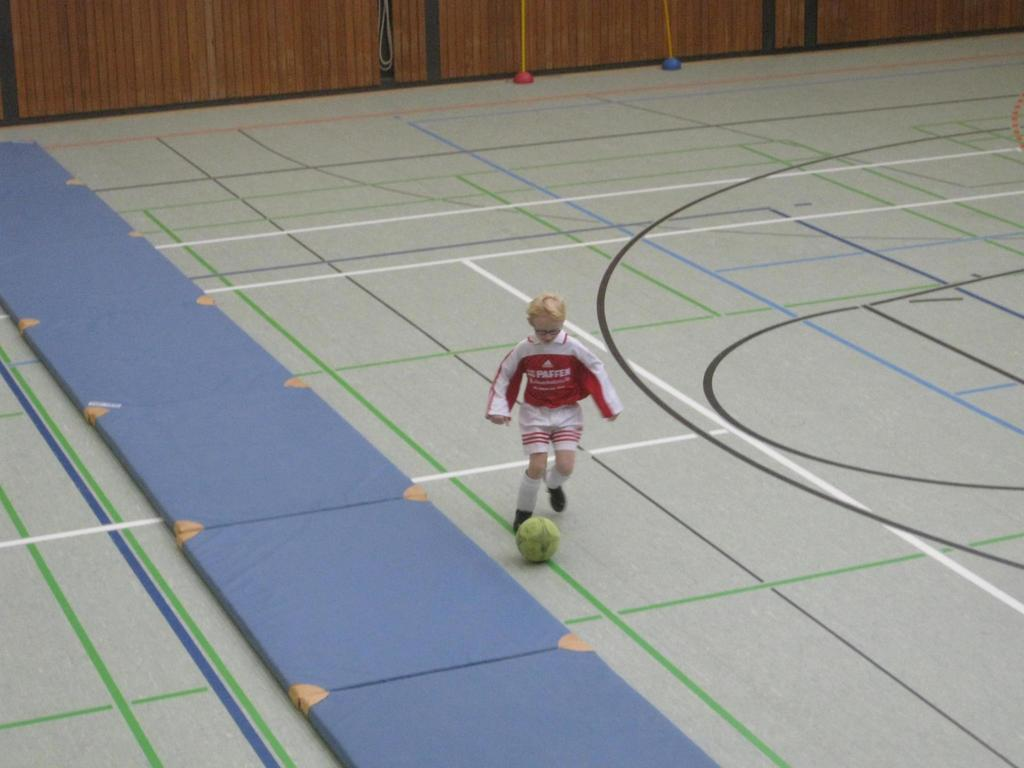<image>
Relay a brief, clear account of the picture shown. A soccer player has a red and white jersey with a word starting with the letter P on it. 